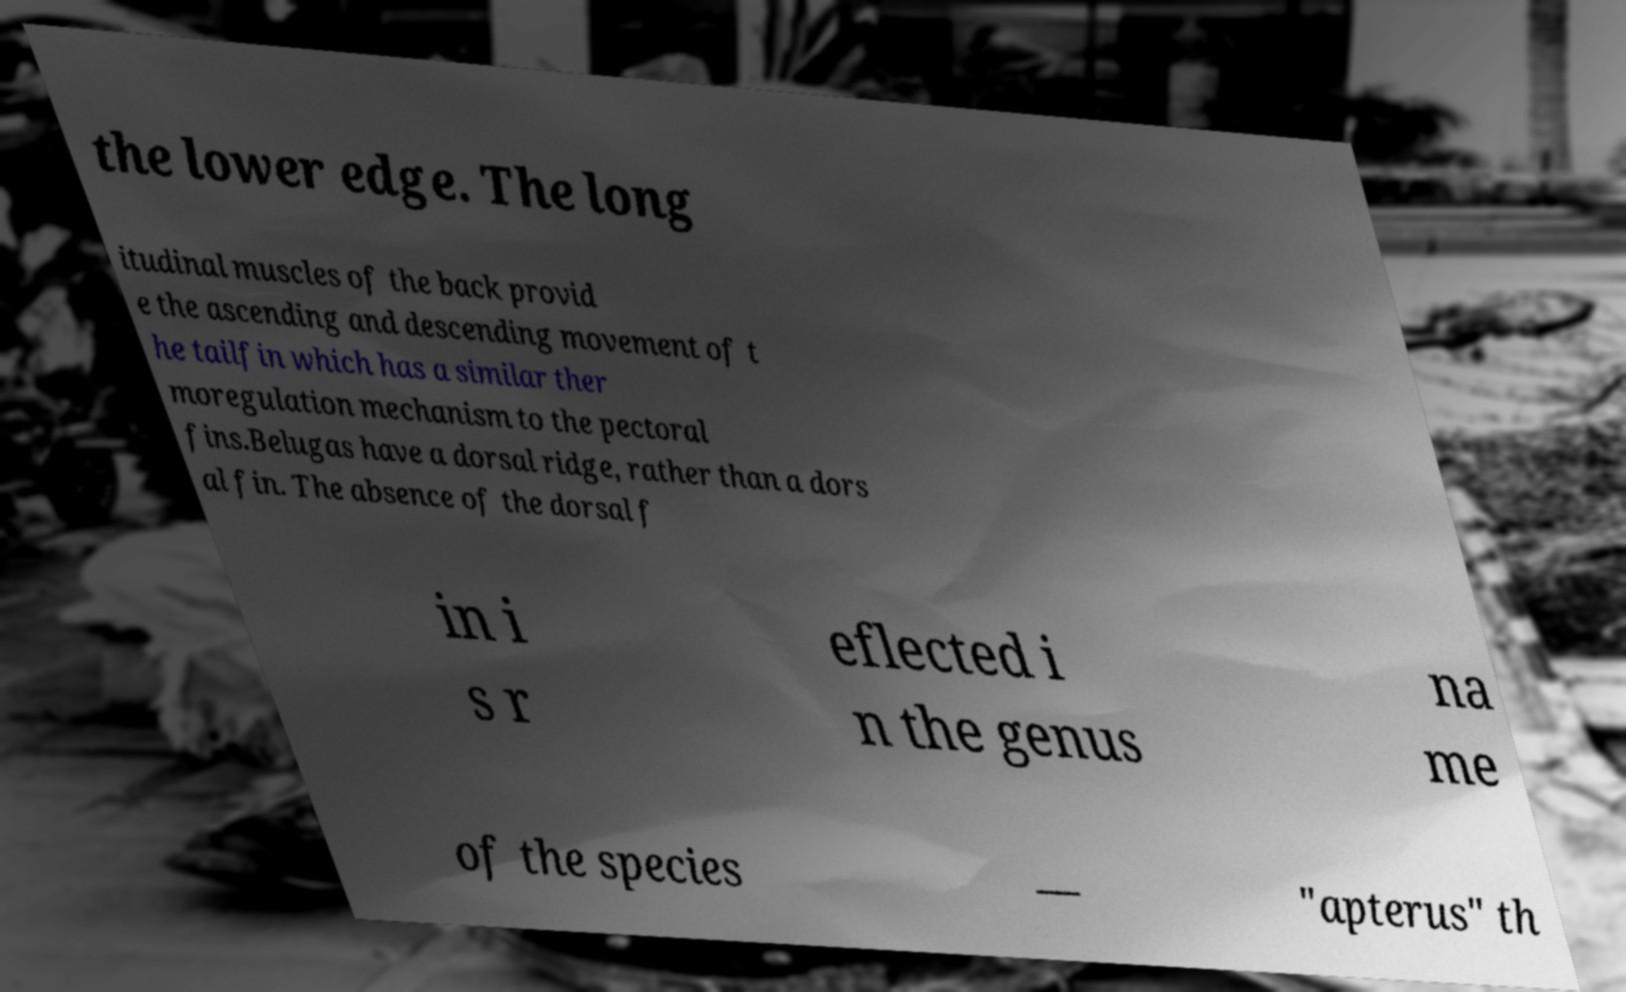Please identify and transcribe the text found in this image. the lower edge. The long itudinal muscles of the back provid e the ascending and descending movement of t he tailfin which has a similar ther moregulation mechanism to the pectoral fins.Belugas have a dorsal ridge, rather than a dors al fin. The absence of the dorsal f in i s r eflected i n the genus na me of the species — "apterus" th 